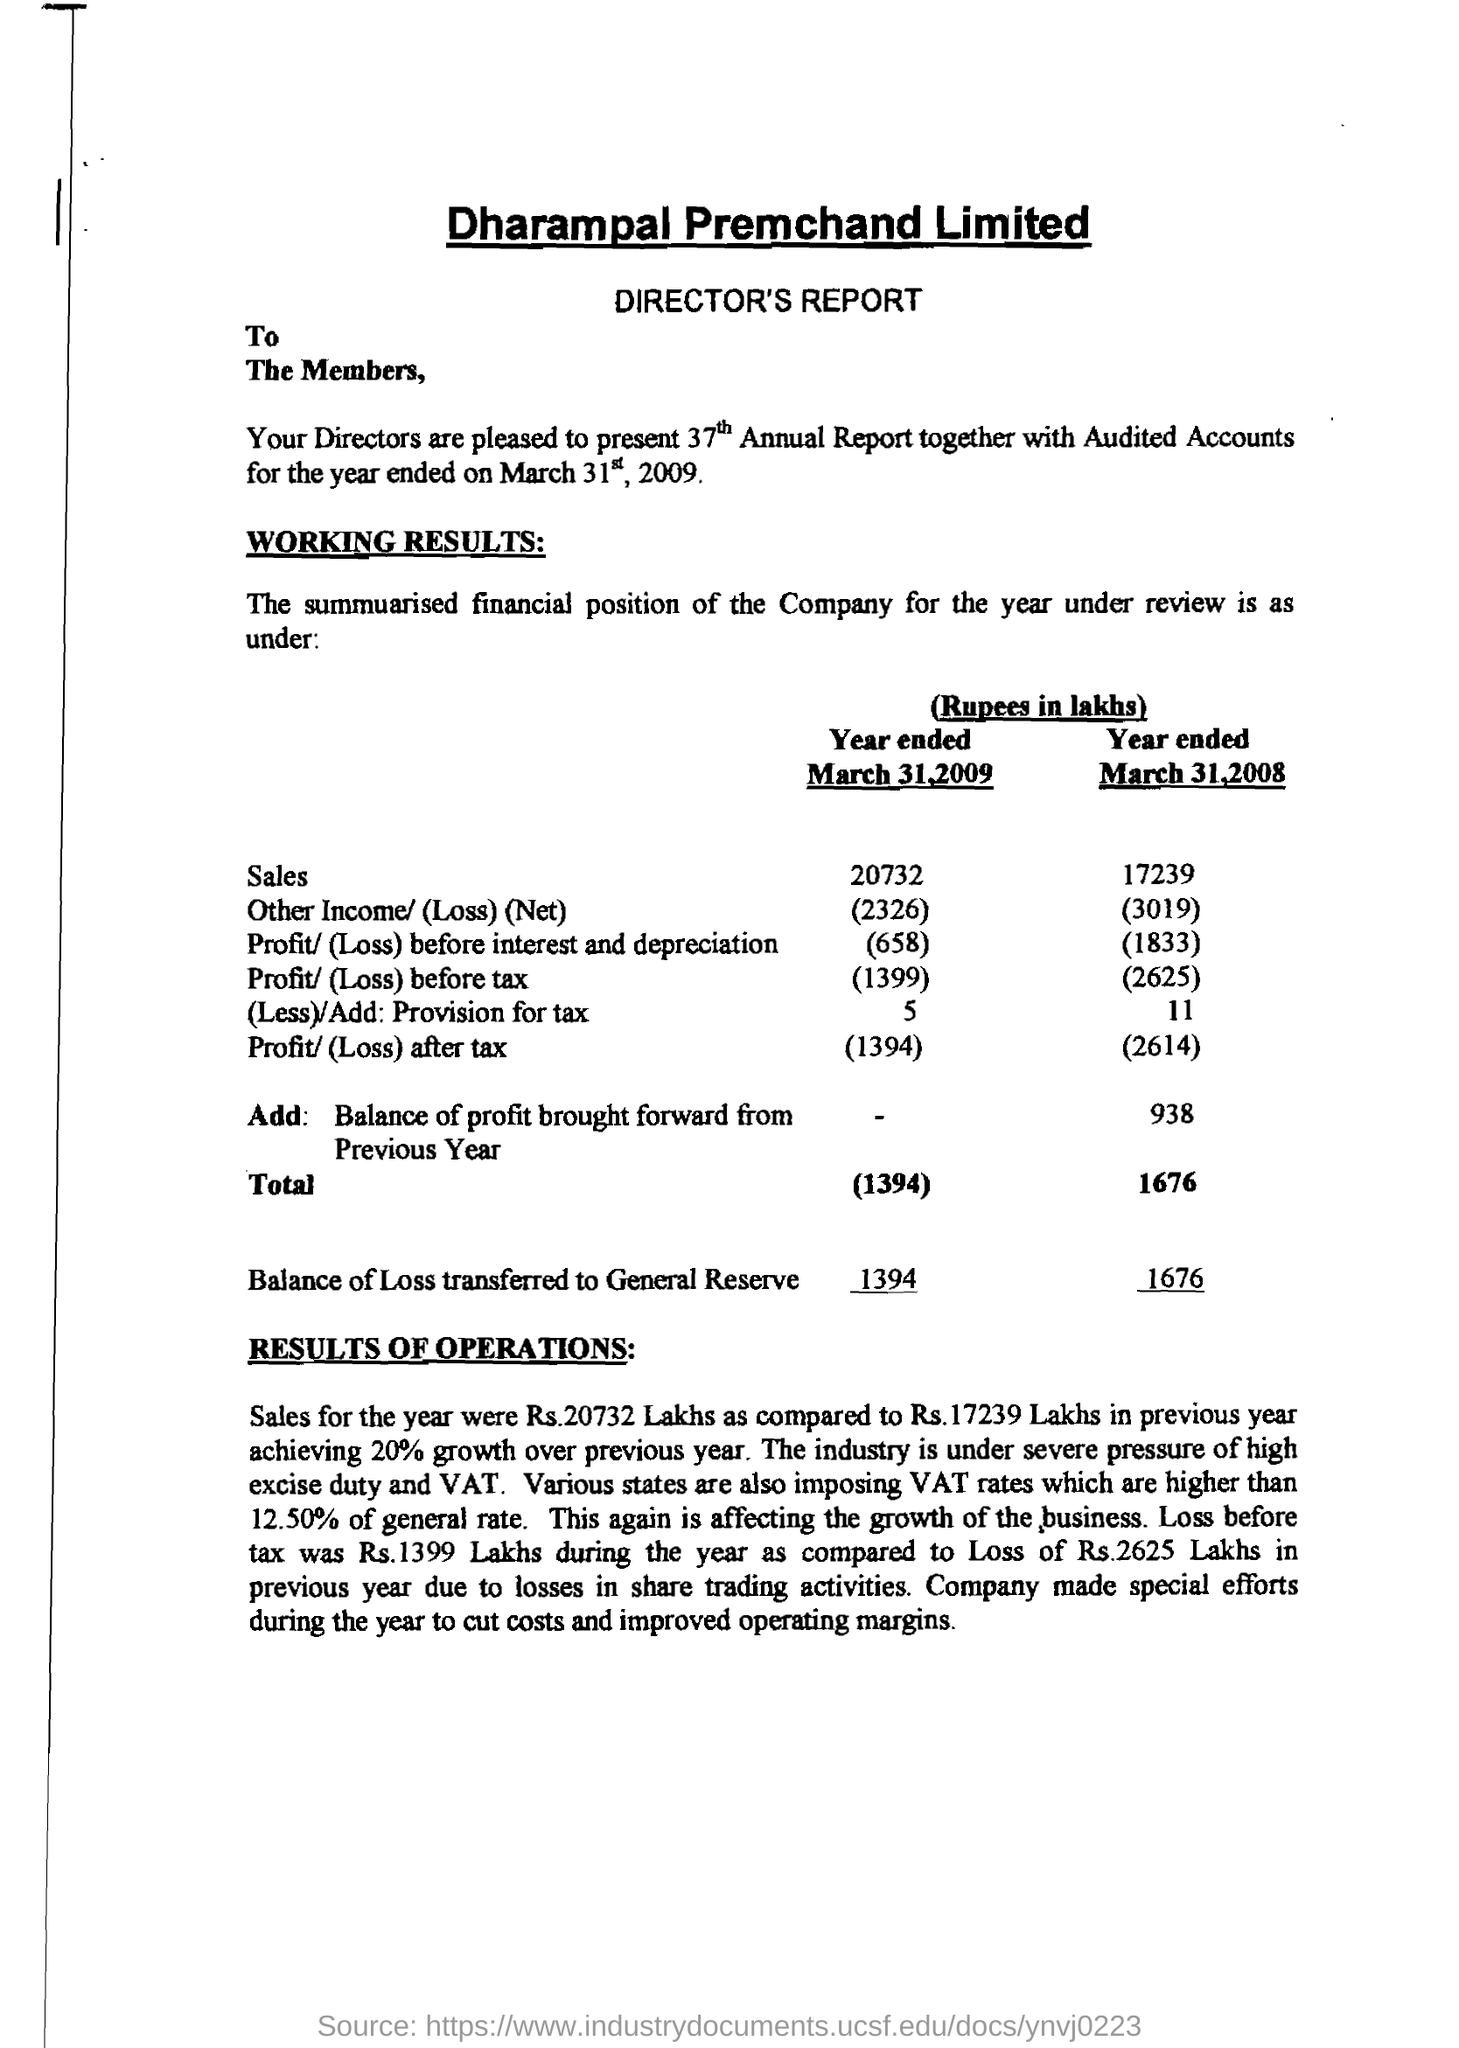How much was the Sales for the year ended march 31, 2009 ?
Your response must be concise. 20732. What % of growth was achieved over the previous year ?
Give a very brief answer. 20%. What was the 'balance of loss transferred to general reserve' for the year ended march 31, 2008 ?
Offer a very short reply. 1676 lakhs. What was the Loss before Tax during the year 2009?
Offer a terse response. 1399 lakhs. What was the 'loss before interest and depreciation' for the year ended in march 31, 2008 ?
Your answer should be very brief. 1833. 